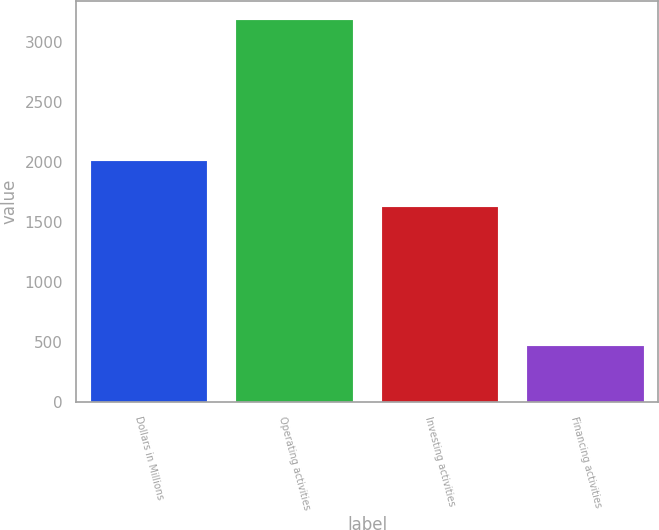Convert chart. <chart><loc_0><loc_0><loc_500><loc_500><bar_chart><fcel>Dollars in Millions<fcel>Operating activities<fcel>Investing activities<fcel>Financing activities<nl><fcel>2004<fcel>3176<fcel>1622<fcel>463<nl></chart> 